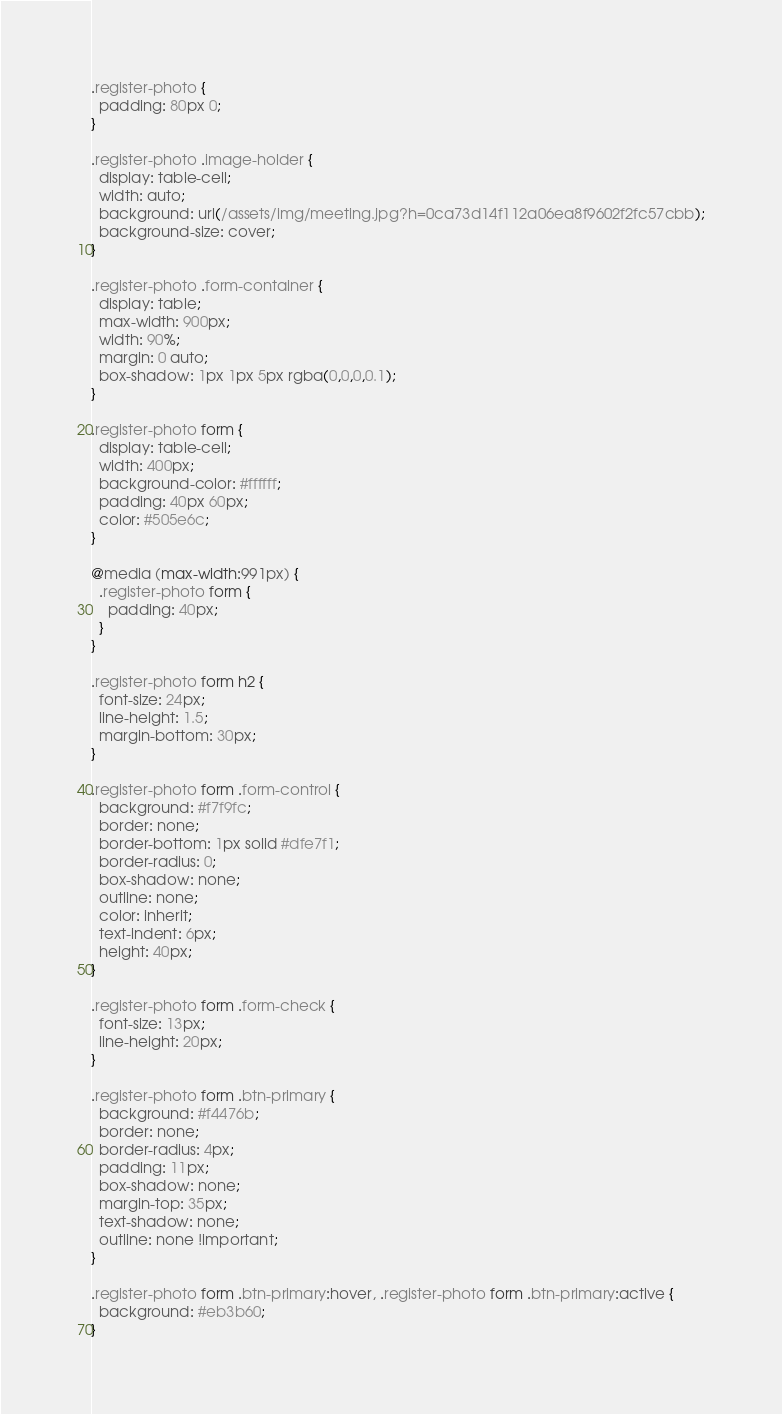<code> <loc_0><loc_0><loc_500><loc_500><_CSS_>.register-photo {
  padding: 80px 0;
}

.register-photo .image-holder {
  display: table-cell;
  width: auto;
  background: url(/assets/img/meeting.jpg?h=0ca73d14f112a06ea8f9602f2fc57cbb);
  background-size: cover;
}

.register-photo .form-container {
  display: table;
  max-width: 900px;
  width: 90%;
  margin: 0 auto;
  box-shadow: 1px 1px 5px rgba(0,0,0,0.1);
}

.register-photo form {
  display: table-cell;
  width: 400px;
  background-color: #ffffff;
  padding: 40px 60px;
  color: #505e6c;
}

@media (max-width:991px) {
  .register-photo form {
    padding: 40px;
  }
}

.register-photo form h2 {
  font-size: 24px;
  line-height: 1.5;
  margin-bottom: 30px;
}

.register-photo form .form-control {
  background: #f7f9fc;
  border: none;
  border-bottom: 1px solid #dfe7f1;
  border-radius: 0;
  box-shadow: none;
  outline: none;
  color: inherit;
  text-indent: 6px;
  height: 40px;
}

.register-photo form .form-check {
  font-size: 13px;
  line-height: 20px;
}

.register-photo form .btn-primary {
  background: #f4476b;
  border: none;
  border-radius: 4px;
  padding: 11px;
  box-shadow: none;
  margin-top: 35px;
  text-shadow: none;
  outline: none !important;
}

.register-photo form .btn-primary:hover, .register-photo form .btn-primary:active {
  background: #eb3b60;
}
</code> 